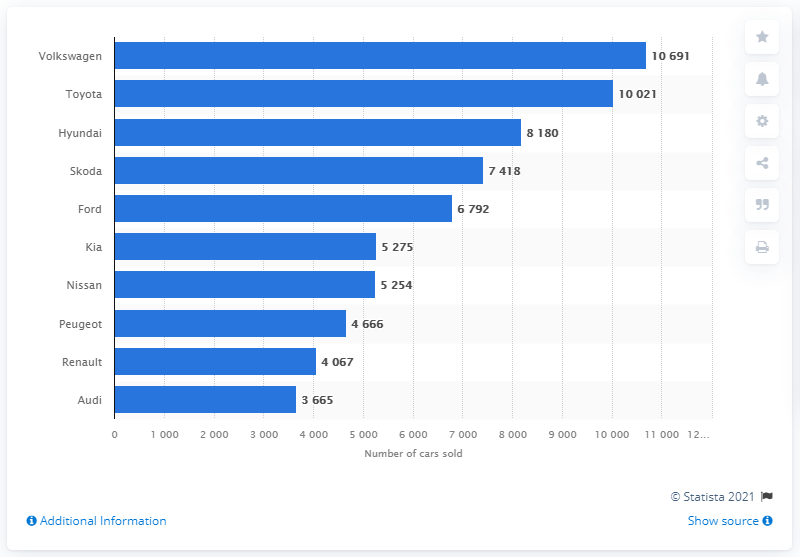Mention a couple of crucial points in this snapshot. In 2020, Volkswagen emerged as the most popular car brand in Ireland, as indicated by the sales figures released by the relevant authorities. 